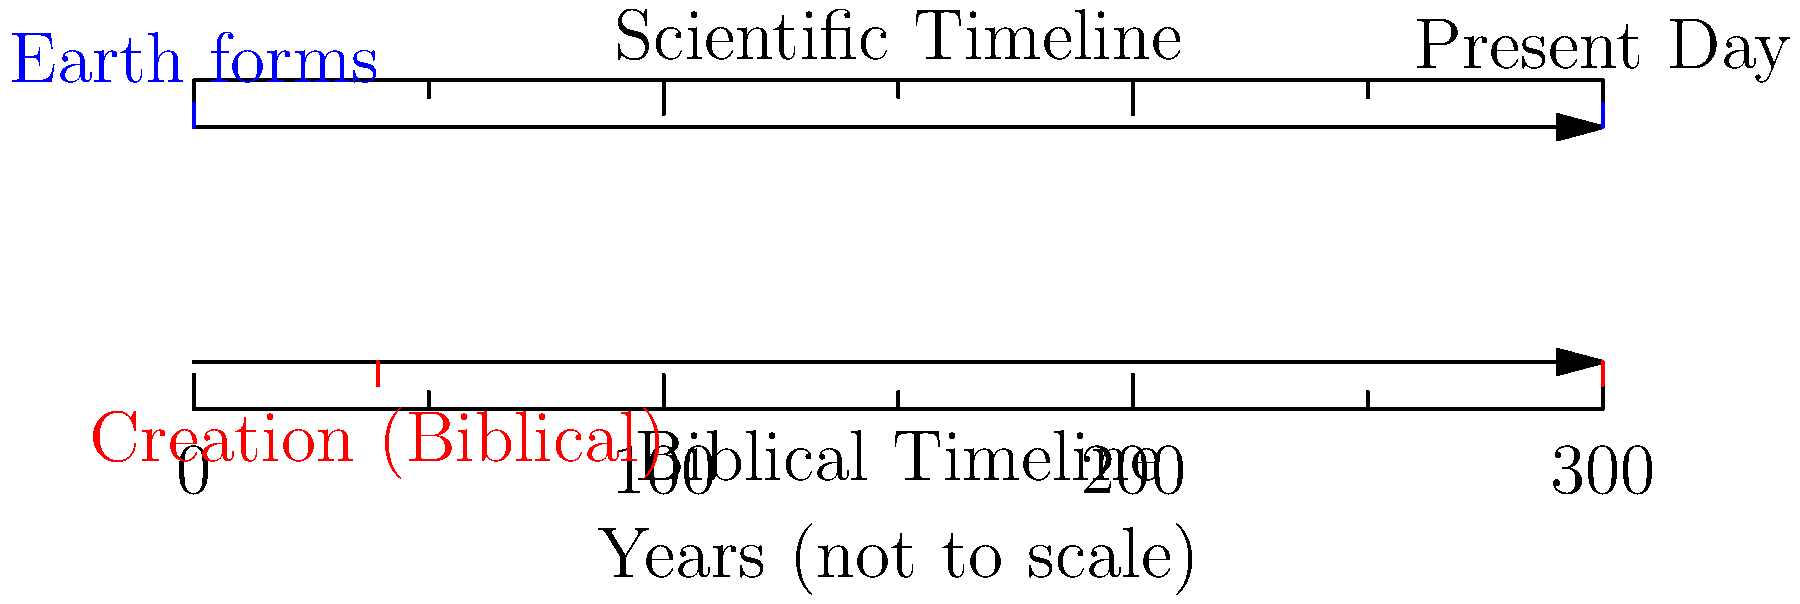Based on the timeline graphic, which perspective suggests a significantly older Earth, and by approximately how many years does it differ from the other view? To answer this question, we need to analyze the timeline graphic and compare the two perspectives:

1. Scientific Timeline:
   - The blue mark on the upper timeline indicates Earth's formation at about 4.6 billion years ago.
   - This is based on radiometric dating of rocks and meteorites.

2. Biblical Timeline:
   - The red mark on the lower timeline shows the Biblical creation at around 4,000 BCE (Before Common Era).
   - This is derived from genealogies and events described in religious texts.

3. Calculating the difference:
   - Scientific age of Earth: 4.6 billion years
   - Biblical age of Earth: Approximately 6,000 years (4,000 BCE + 2,023 CE)
   - Difference: 4,600,000,000 - 6,000 = 4,599,994,000 years

4. Conclusion:
   - The scientific perspective suggests a significantly older Earth.
   - The difference is approximately 4.6 billion years.
Answer: Scientific; ~4.6 billion years older 